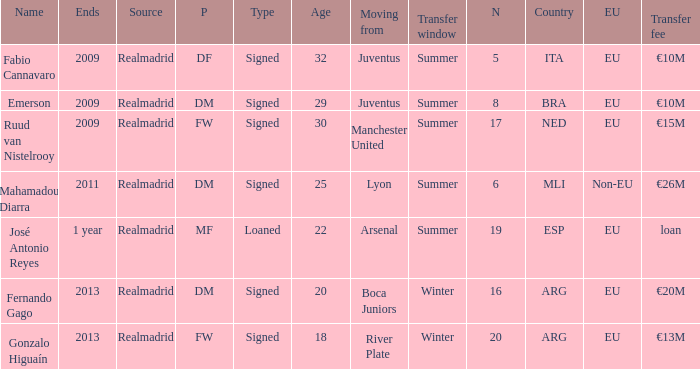How many numbers are ending in 1 year? 1.0. 